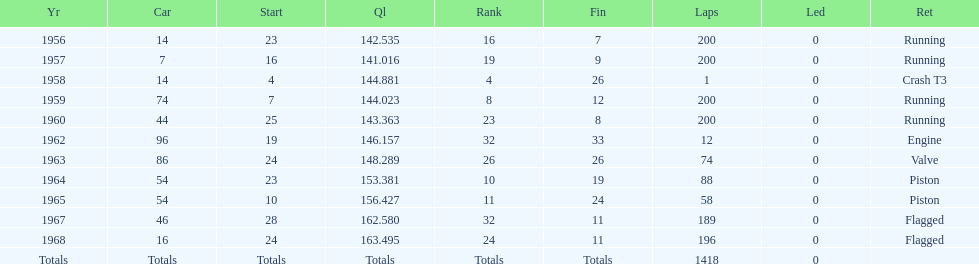Did bob veith drive more indy 500 laps in the 1950s or 1960s? 1960s. 